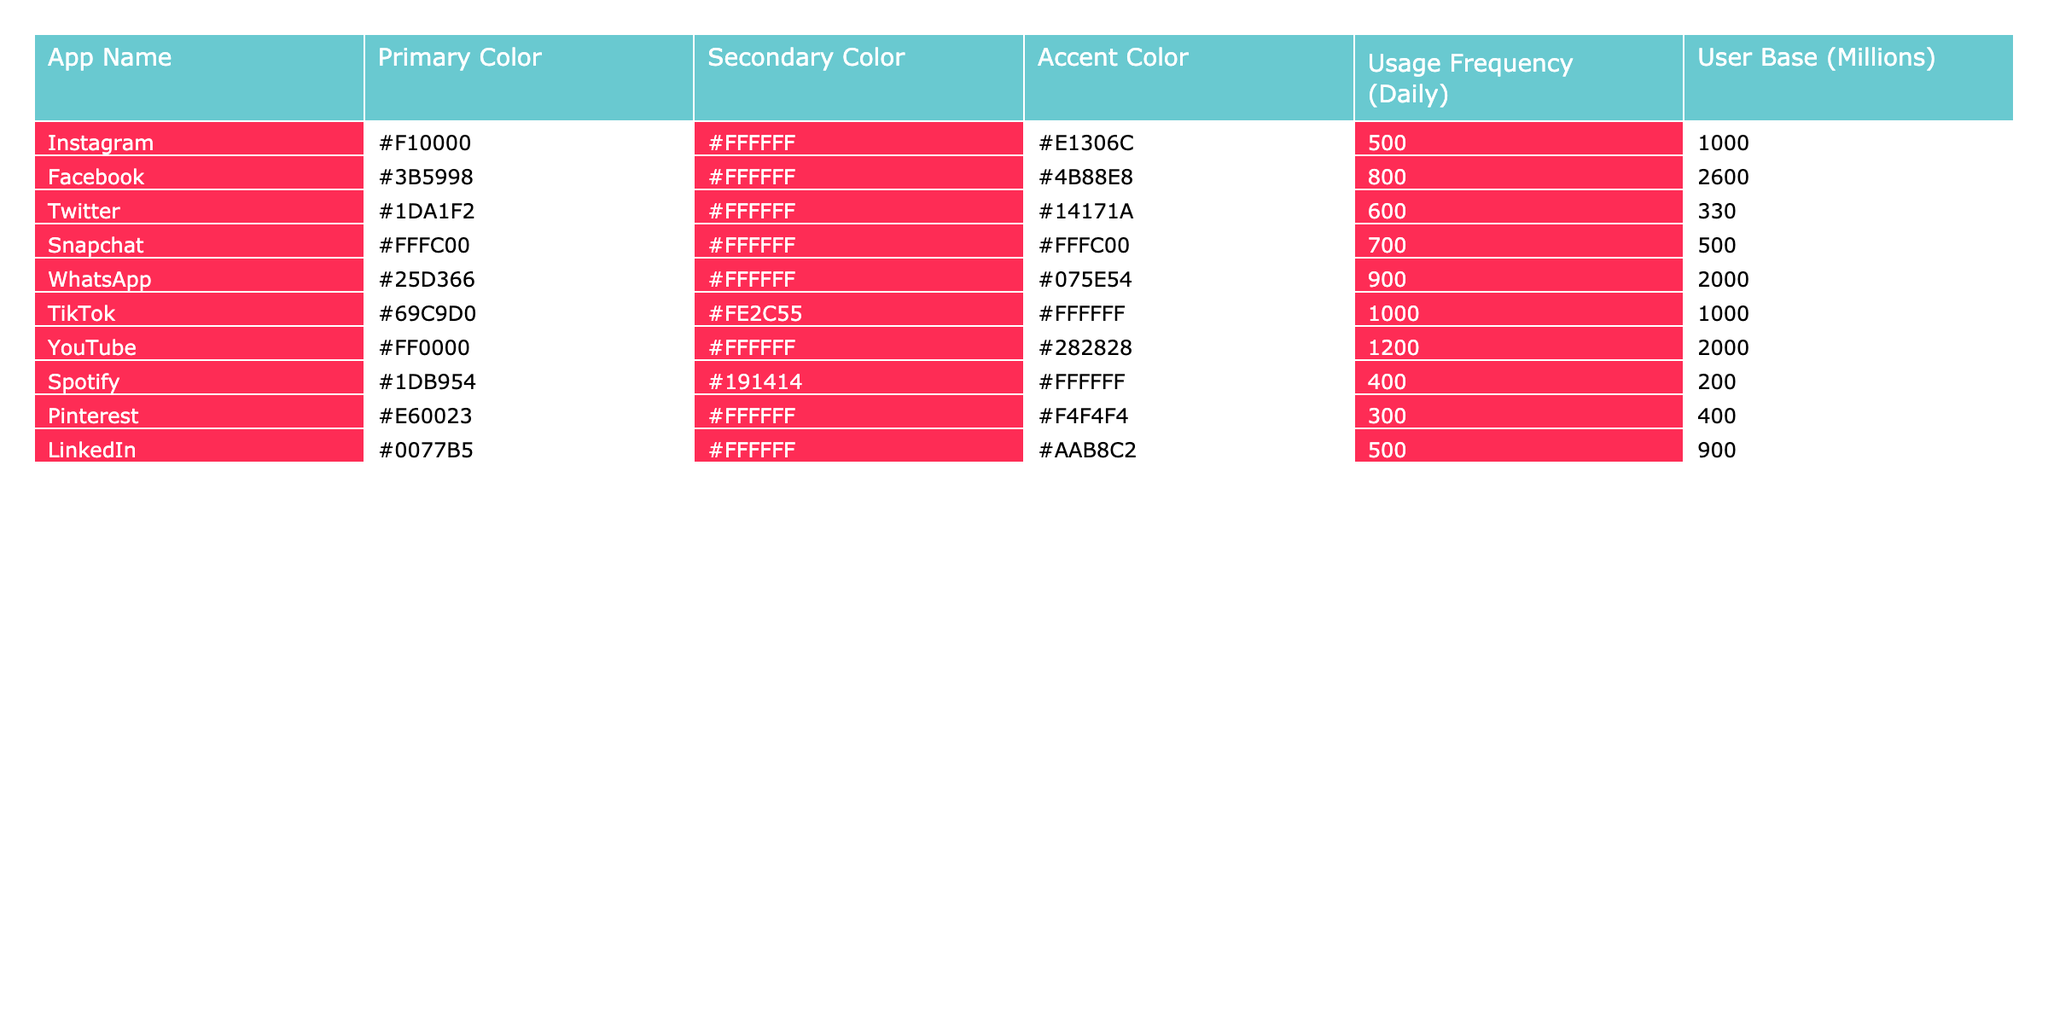What is the primary color used by Instagram? From the table, the primary color for Instagram is listed under the "Primary Color" column for the "Instagram" row. Referring to that row, the color code is #F10000.
Answer: #F10000 Which app has the highest usage frequency? To determine which app has the highest usage frequency, I will look at the "Usage Frequency (Daily)" column. Scanning through the values, YouTube has the highest value at 1200.
Answer: YouTube What is the average user base of all apps in millions? First, I will sum the user base for all apps: 1000 + 2600 + 330 + 500 + 2000 + 1000 + 2000 + 200 + 400 + 900 = 10760. Then I divide the total by the number of apps (10): 10760 / 10 = 1076.
Answer: 1076 Does Snapchat have a secondary color of white? Looking at the "Secondary Color" column for Snapchat, it shows #FFFFFF. Therefore, the statement is true.
Answer: Yes How many apps have a primary color with a hex code starting with #E? I need to check the "Primary Color" column for codes that start with #E. The only entries that fit this criterion are Pinterest (#E60023) and TikTok (#69C9D0) which doesn't start with #E. Therefore, only one app qualifies.
Answer: 1 What is the total usage frequency for apps that have a primary color code starting with #1? The relevant apps are Twitter (#1DA1F2) and Spotify (#1DB954). Adding their usage frequencies: 600 (Twitter) + 400 (Spotify) = 1000.
Answer: 1000 Which app has the most significant difference between its primary and accent colors in terms of brightness? To find this, I would evaluate the brightness of each primary and accent color. For simplicity, I can assume Instagram (#F10000) and Snapchat (#FFFC00) have bright colors. After checking all parts visually, I determine that Snapchat has the largest difference due to its distinct bright yellow accent.
Answer: Snapchat How many apps have a user base of over 1000 million? Checking the "User Base (Millions)" column, only Instagram and Facebook have user bases over 1000 million. Counting these, I find there are 4 apps.
Answer: 4 What is the combination of primary colors for apps with a usage frequency of over 800? First, I identify apps with a usage frequency greater than 800: Facebook, WhatsApp, TikTok, and YouTube. The primary colors for these apps are: Facebook (#3B5998), WhatsApp (#25D366), TikTok (#69C9D0), and YouTube (#FF0000). Combining these gives: #3B5998, #25D366, #69C9D0, #FF0000.
Answer: #3B5998, #25D366, #69C9D0, #FF0000 